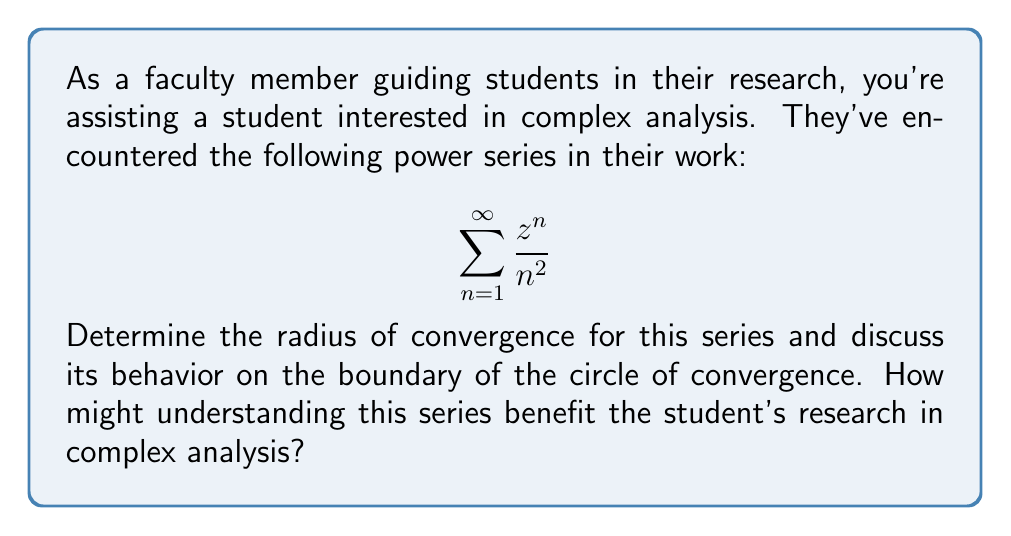Can you answer this question? Let's approach this step-by-step:

1) To find the radius of convergence, we'll use the ratio test:

   $$R = \lim_{n \to \infty} \left|\frac{a_n}{a_{n+1}}\right|$$

   where $a_n = \frac{1}{n^2}$ for our series.

2) Applying the ratio test:

   $$\begin{align}
   R &= \lim_{n \to \infty} \left|\frac{\frac{1}{n^2}}{\frac{1}{(n+1)^2}}\right| \\
   &= \lim_{n \to \infty} \left|\frac{(n+1)^2}{n^2}\right| \\
   &= \lim_{n \to \infty} \left(1 + \frac{2}{n} + \frac{1}{n^2}\right) \\
   &= 1
   \end{align}$$

3) Therefore, the radius of convergence is 1. The series converges for $|z| < 1$ and diverges for $|z| > 1$.

4) On the boundary where $|z| = 1$, we need to check separately. The series becomes:

   $$\sum_{n=1}^{\infty} \frac{e^{i\theta n}}{n^2}$$

5) This is a Dirichlet series which converges absolutely for all real $\theta$. Therefore, the series converges on the entire boundary $|z| = 1$.

6) Understanding this series is beneficial for research in complex analysis because:
   - It demonstrates the application of convergence tests for complex series.
   - It shows how a series can behave differently inside, outside, and on the boundary of its circle of convergence.
   - It introduces the student to important functions in complex analysis, as this series is related to the dilogarithm function.
Answer: Radius of convergence: 1. Converges for $|z| \leq 1$, diverges for $|z| > 1$. 